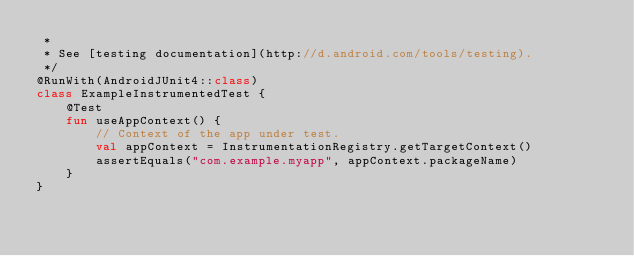Convert code to text. <code><loc_0><loc_0><loc_500><loc_500><_Kotlin_> *
 * See [testing documentation](http://d.android.com/tools/testing).
 */
@RunWith(AndroidJUnit4::class)
class ExampleInstrumentedTest {
    @Test
    fun useAppContext() {
        // Context of the app under test.
        val appContext = InstrumentationRegistry.getTargetContext()
        assertEquals("com.example.myapp", appContext.packageName)
    }
}
</code> 